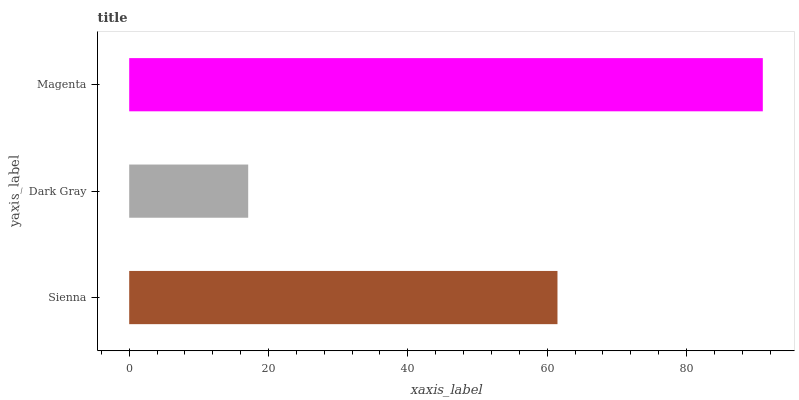Is Dark Gray the minimum?
Answer yes or no. Yes. Is Magenta the maximum?
Answer yes or no. Yes. Is Magenta the minimum?
Answer yes or no. No. Is Dark Gray the maximum?
Answer yes or no. No. Is Magenta greater than Dark Gray?
Answer yes or no. Yes. Is Dark Gray less than Magenta?
Answer yes or no. Yes. Is Dark Gray greater than Magenta?
Answer yes or no. No. Is Magenta less than Dark Gray?
Answer yes or no. No. Is Sienna the high median?
Answer yes or no. Yes. Is Sienna the low median?
Answer yes or no. Yes. Is Dark Gray the high median?
Answer yes or no. No. Is Magenta the low median?
Answer yes or no. No. 